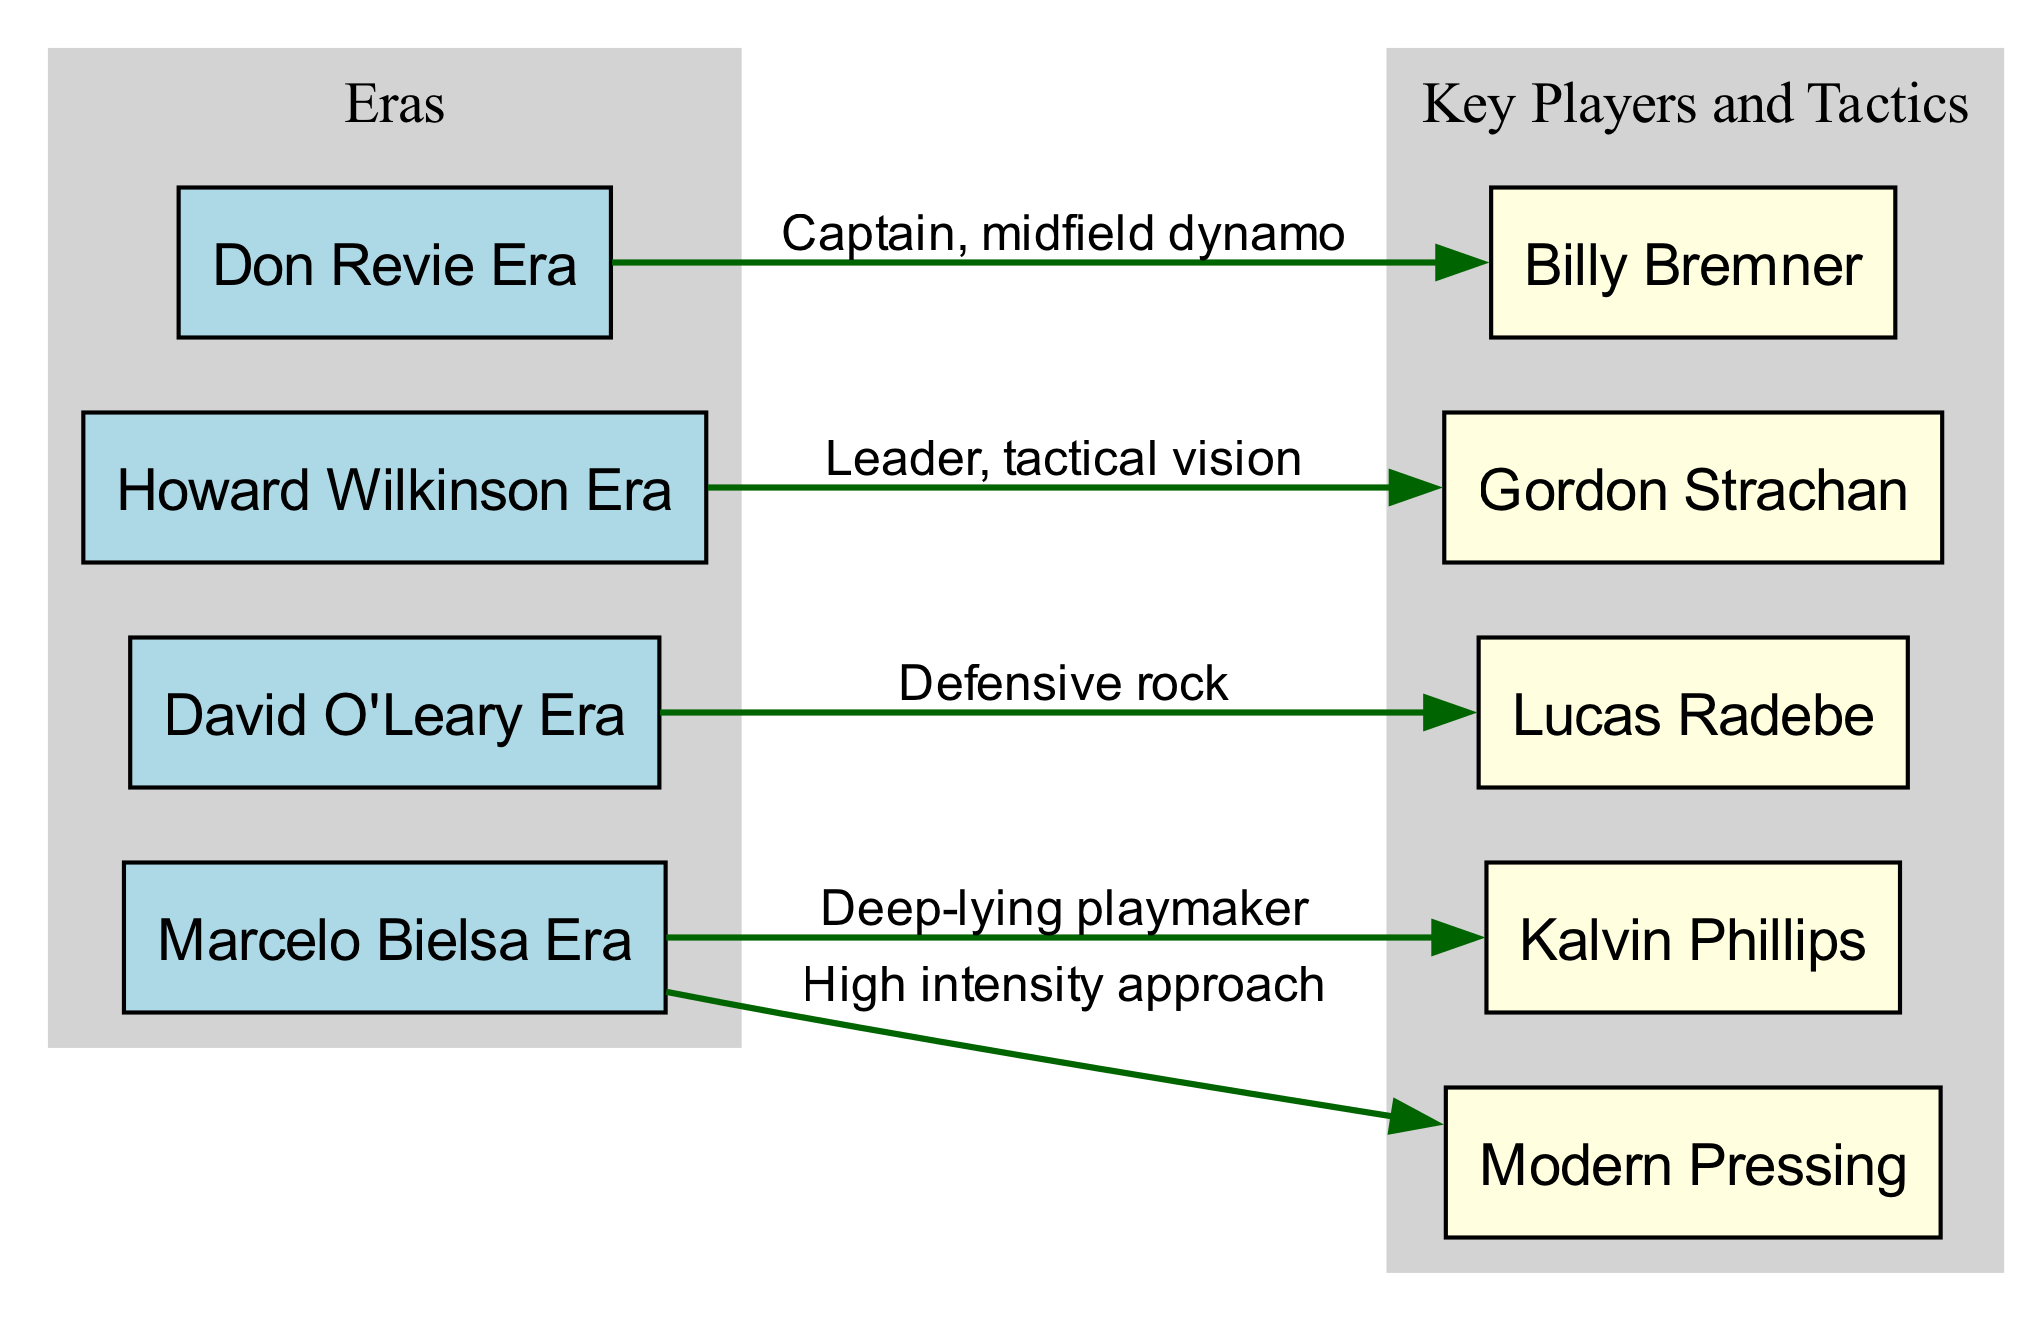What era is associated with Billy Bremner? The diagram shows an edge from the "Don Revie Era" node (A1) to the "Billy Bremner" node (B1), indicating that Billy Bremner is associated with this era.
Answer: Don Revie Era How many key players are linked to the Marcelo Bielsa Era? The diagram indicates that there are two edges going from the "Marcelo Bielsa Era" node (A4) to the "Kalvin Phillips" node (B4) and the "Modern Pressing" node (B5). Thus, there are two key players or tactical influences linked to this era.
Answer: 2 What is the relationship between Gordon Strachan and his era? The diagram has an edge from the "Howard Wilkinson Era" node (A2) to the "Gordon Strachan" node (B2) with the label "Leader, tactical vision," indicating that he played a significant role as a leader with tactical insight during this era.
Answer: Leader, tactical vision Which player is depicted as a "defensive rock"? The edge from the "David O'Leary Era" node (A3) points to the "Lucas Radebe" node (B3), with the label "Defensive rock," identifying Lucas Radebe as this player associated with that description.
Answer: Lucas Radebe What tactical approach is associated with the Marcelo Bielsa Era? There are two edges stemming from the "Marcelo Bielsa Era" node (A4). One connects to "Kalvin Phillips" (B4) and the other to "Modern Pressing" (B5), revealing that "High intensity approach" is a direct product of this era, represented by "Modern Pressing."
Answer: High intensity approach What label describes the role of Billy Bremner? The relationship between the "Don Revie Era" node (A1) and the "Billy Bremner" node (B1) has the label "Captain, midfield dynamo," identifying Billy Bremner's significant contribution in this role.
Answer: Captain, midfield dynamo Which eras are linked to key players in the diagram? Each era node (A1 to A4) directly connects to its corresponding key player node (B1 to B4), revealing that they are all linked. Thus, four eras are depicted with these connections, showing that the diagram covers all four eras.
Answer: 4 What position does Kalvin Phillips play according to the diagram? The edge extending from the "Marcelo Bielsa Era" node (A4) to the "Kalvin Phillips" node (B4) is labeled "Deep-lying playmaker," indicating the position that Kalvin Phillips occupied during this era.
Answer: Deep-lying playmaker 